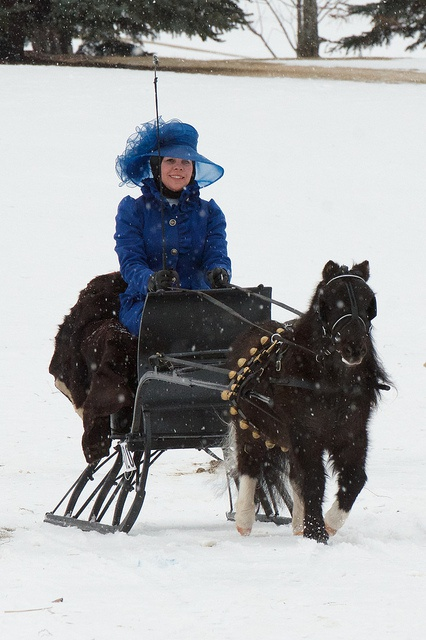Describe the objects in this image and their specific colors. I can see horse in black, gray, and darkgray tones and people in black, navy, white, and blue tones in this image. 